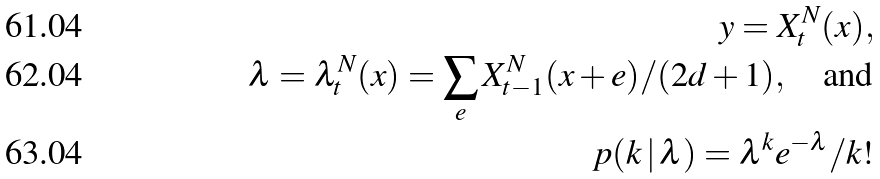<formula> <loc_0><loc_0><loc_500><loc_500>y = X _ { t } ^ { N } ( x ) , \\ \lambda = \lambda ^ { N } _ { t } ( x ) = \sum _ { e } X ^ { N } _ { t - 1 } ( x + e ) / ( 2 d + 1 ) , \quad \text {and} \\ p ( k \, | \, \lambda ) = \lambda ^ { k } e ^ { - \lambda } / k !</formula> 